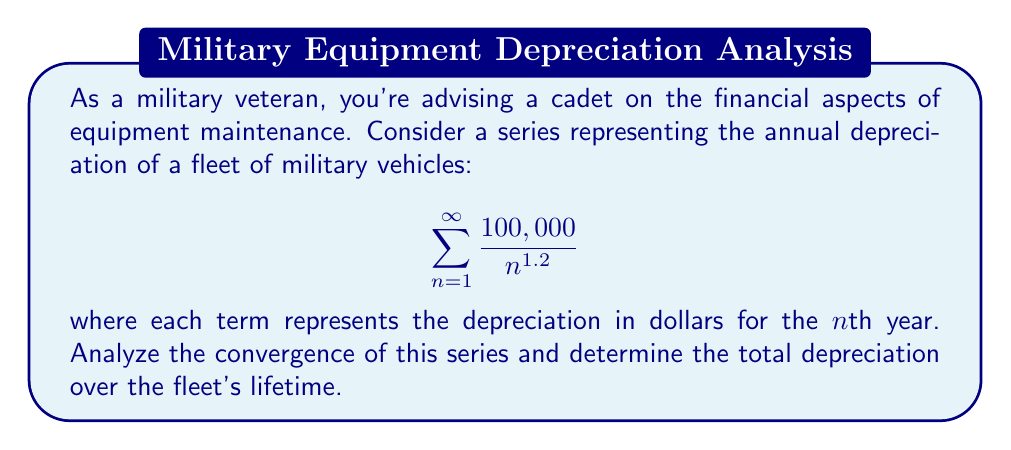Could you help me with this problem? Let's approach this step-by-step:

1) First, we need to determine if this series converges. We can use the p-series test for this.

2) The general form of a p-series is:

   $$\sum_{n=1}^{\infty} \frac{1}{n^p}$$

3) In our case, $p = 1.2$ and we have a constant factor of 100,000.

4) For a p-series:
   - If $p > 1$, the series converges
   - If $p \leq 1$, the series diverges

5) Since $p = 1.2 > 1$, our series converges.

6) To find the sum, we can use the fact that for $p > 1$:

   $$\sum_{n=1}^{\infty} \frac{1}{n^p} = \zeta(p)$$

   where $\zeta(p)$ is the Riemann zeta function.

7) For $p = 1.2$, $\zeta(1.2) \approx 5.591644$.

8) Therefore, our sum is approximately:

   $$100,000 \cdot \zeta(1.2) \approx 100,000 \cdot 5.591644 = 559,164.4$$

9) This means the total depreciation over the fleet's lifetime is about $559,164.40.
Answer: The series converges, with a sum of approximately $559,164.40. 